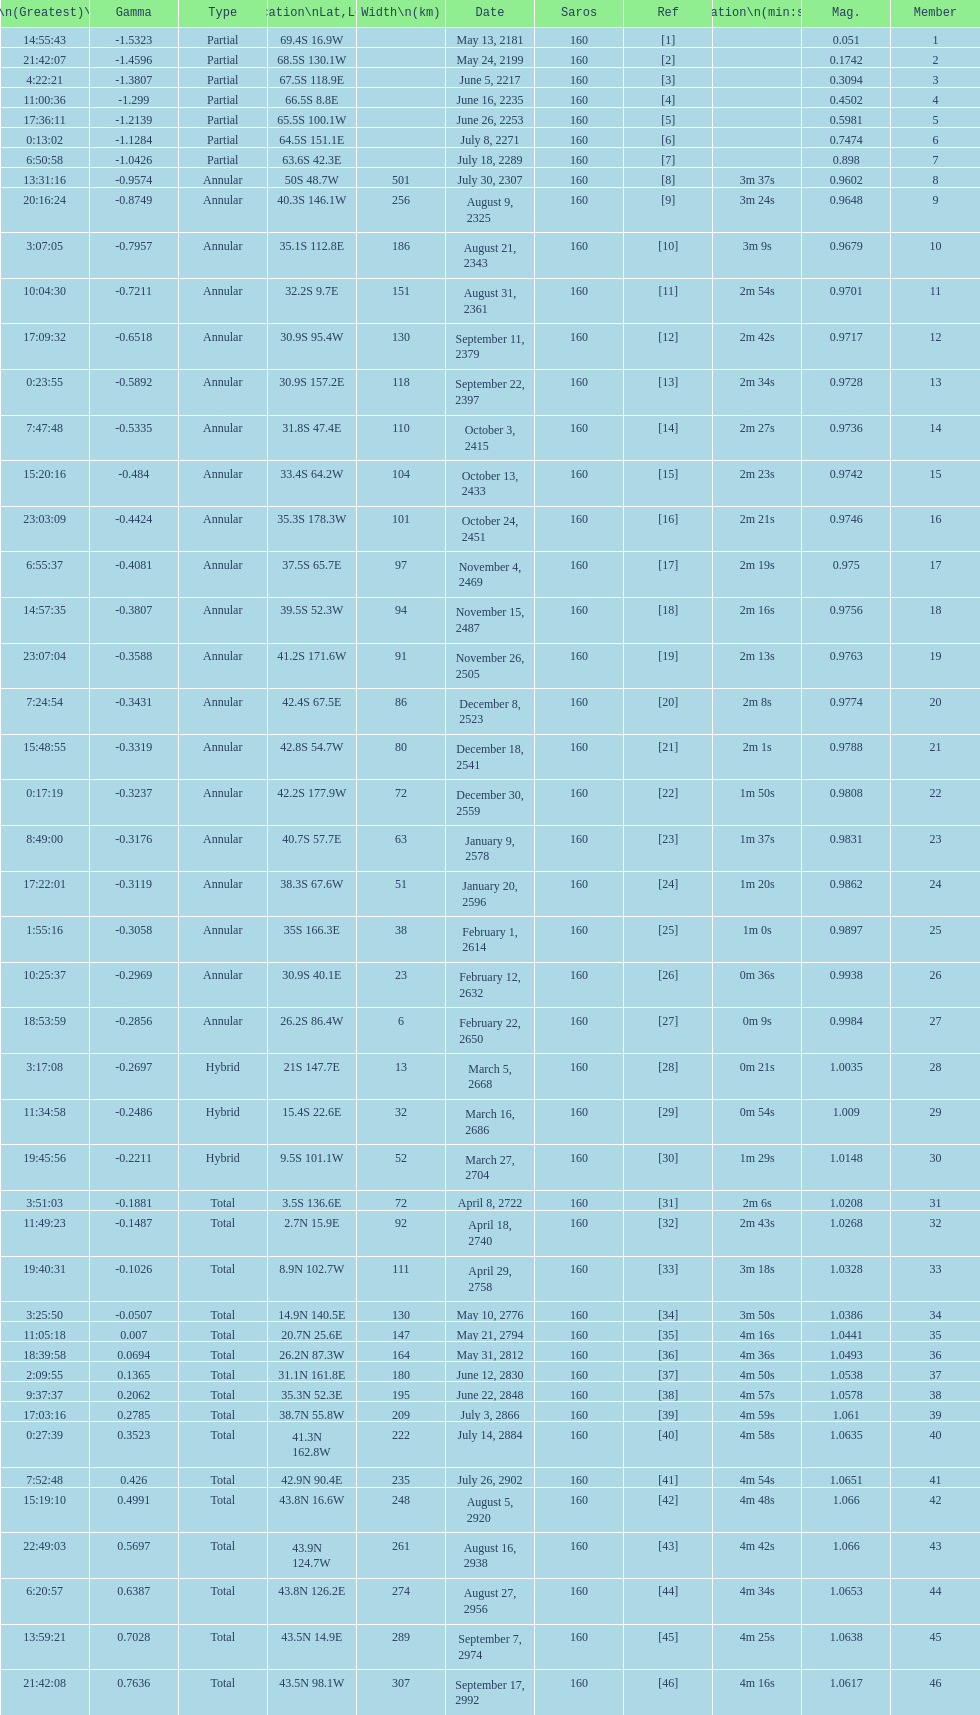How long did the the saros on july 30, 2307 last for? 3m 37s. 